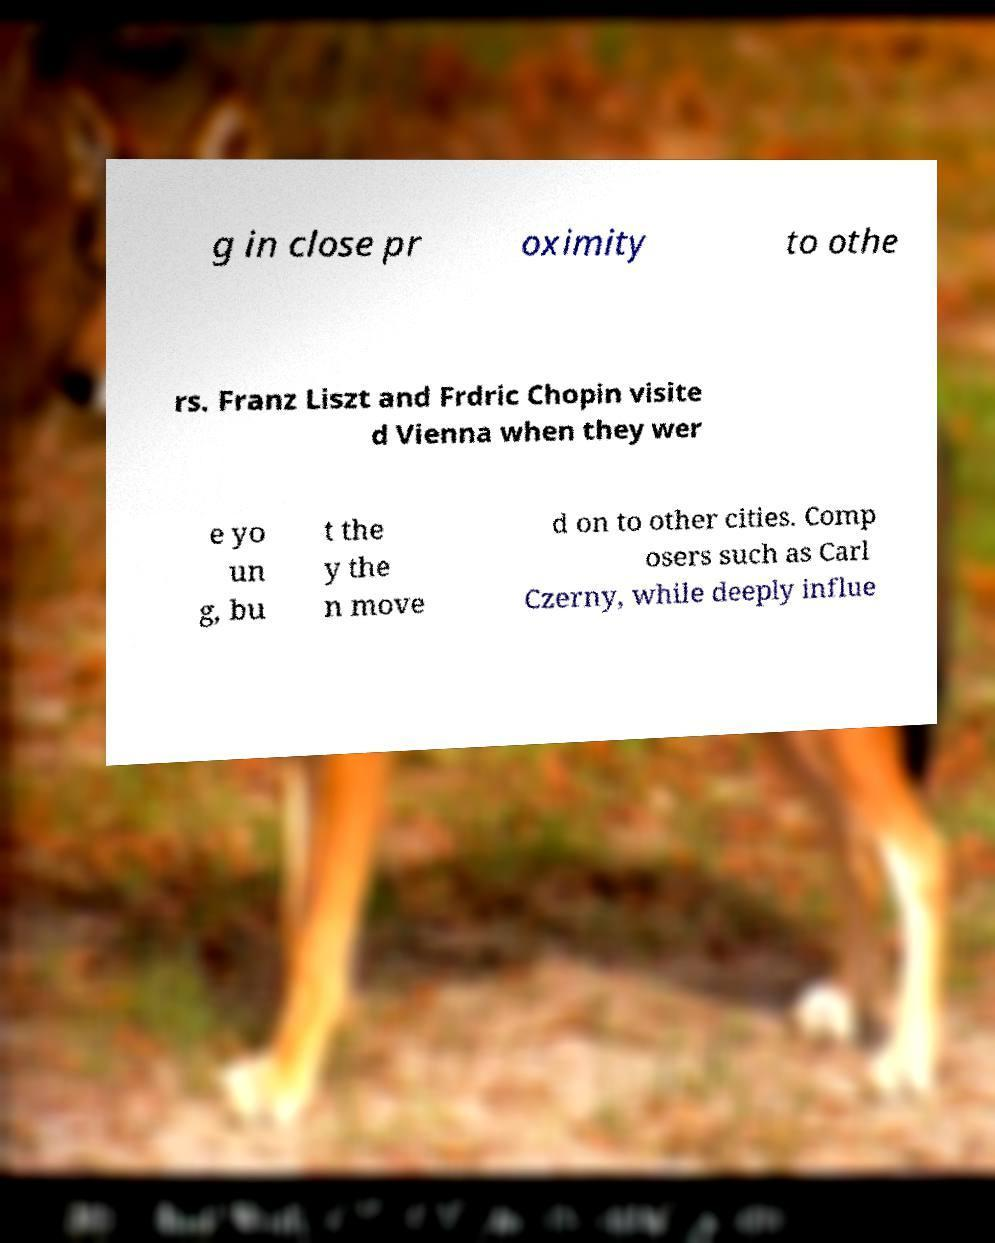Can you accurately transcribe the text from the provided image for me? g in close pr oximity to othe rs. Franz Liszt and Frdric Chopin visite d Vienna when they wer e yo un g, bu t the y the n move d on to other cities. Comp osers such as Carl Czerny, while deeply influe 